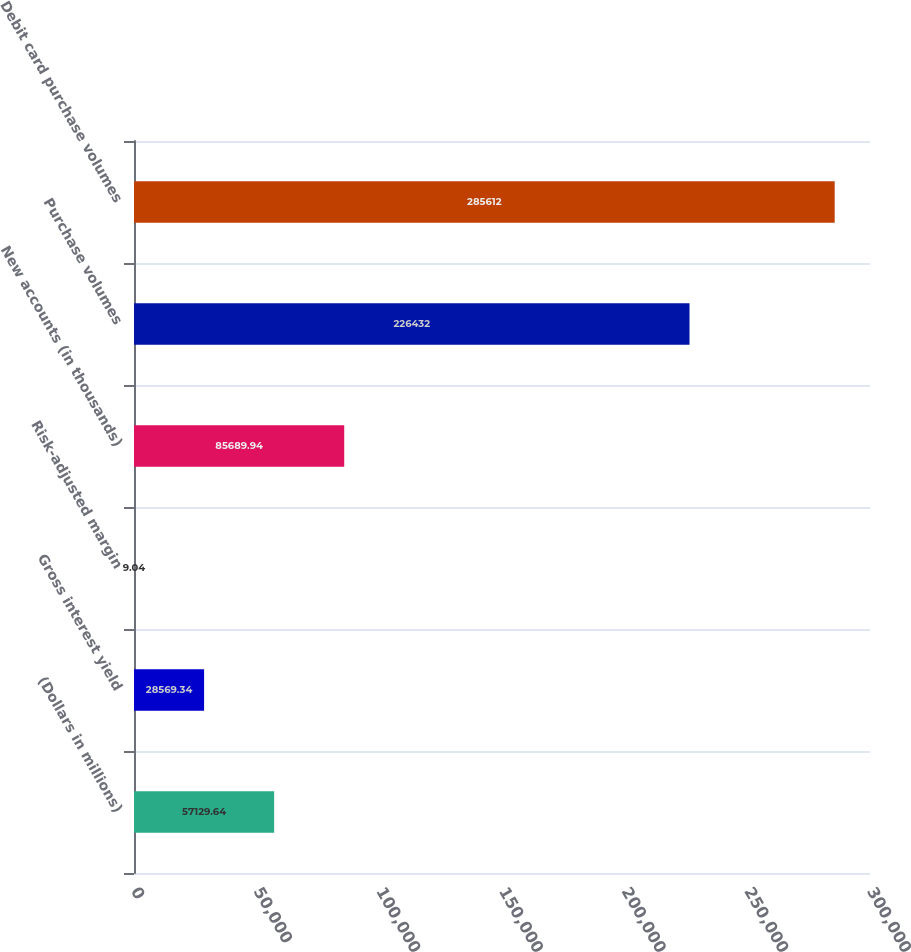Convert chart to OTSL. <chart><loc_0><loc_0><loc_500><loc_500><bar_chart><fcel>(Dollars in millions)<fcel>Gross interest yield<fcel>Risk-adjusted margin<fcel>New accounts (in thousands)<fcel>Purchase volumes<fcel>Debit card purchase volumes<nl><fcel>57129.6<fcel>28569.3<fcel>9.04<fcel>85689.9<fcel>226432<fcel>285612<nl></chart> 